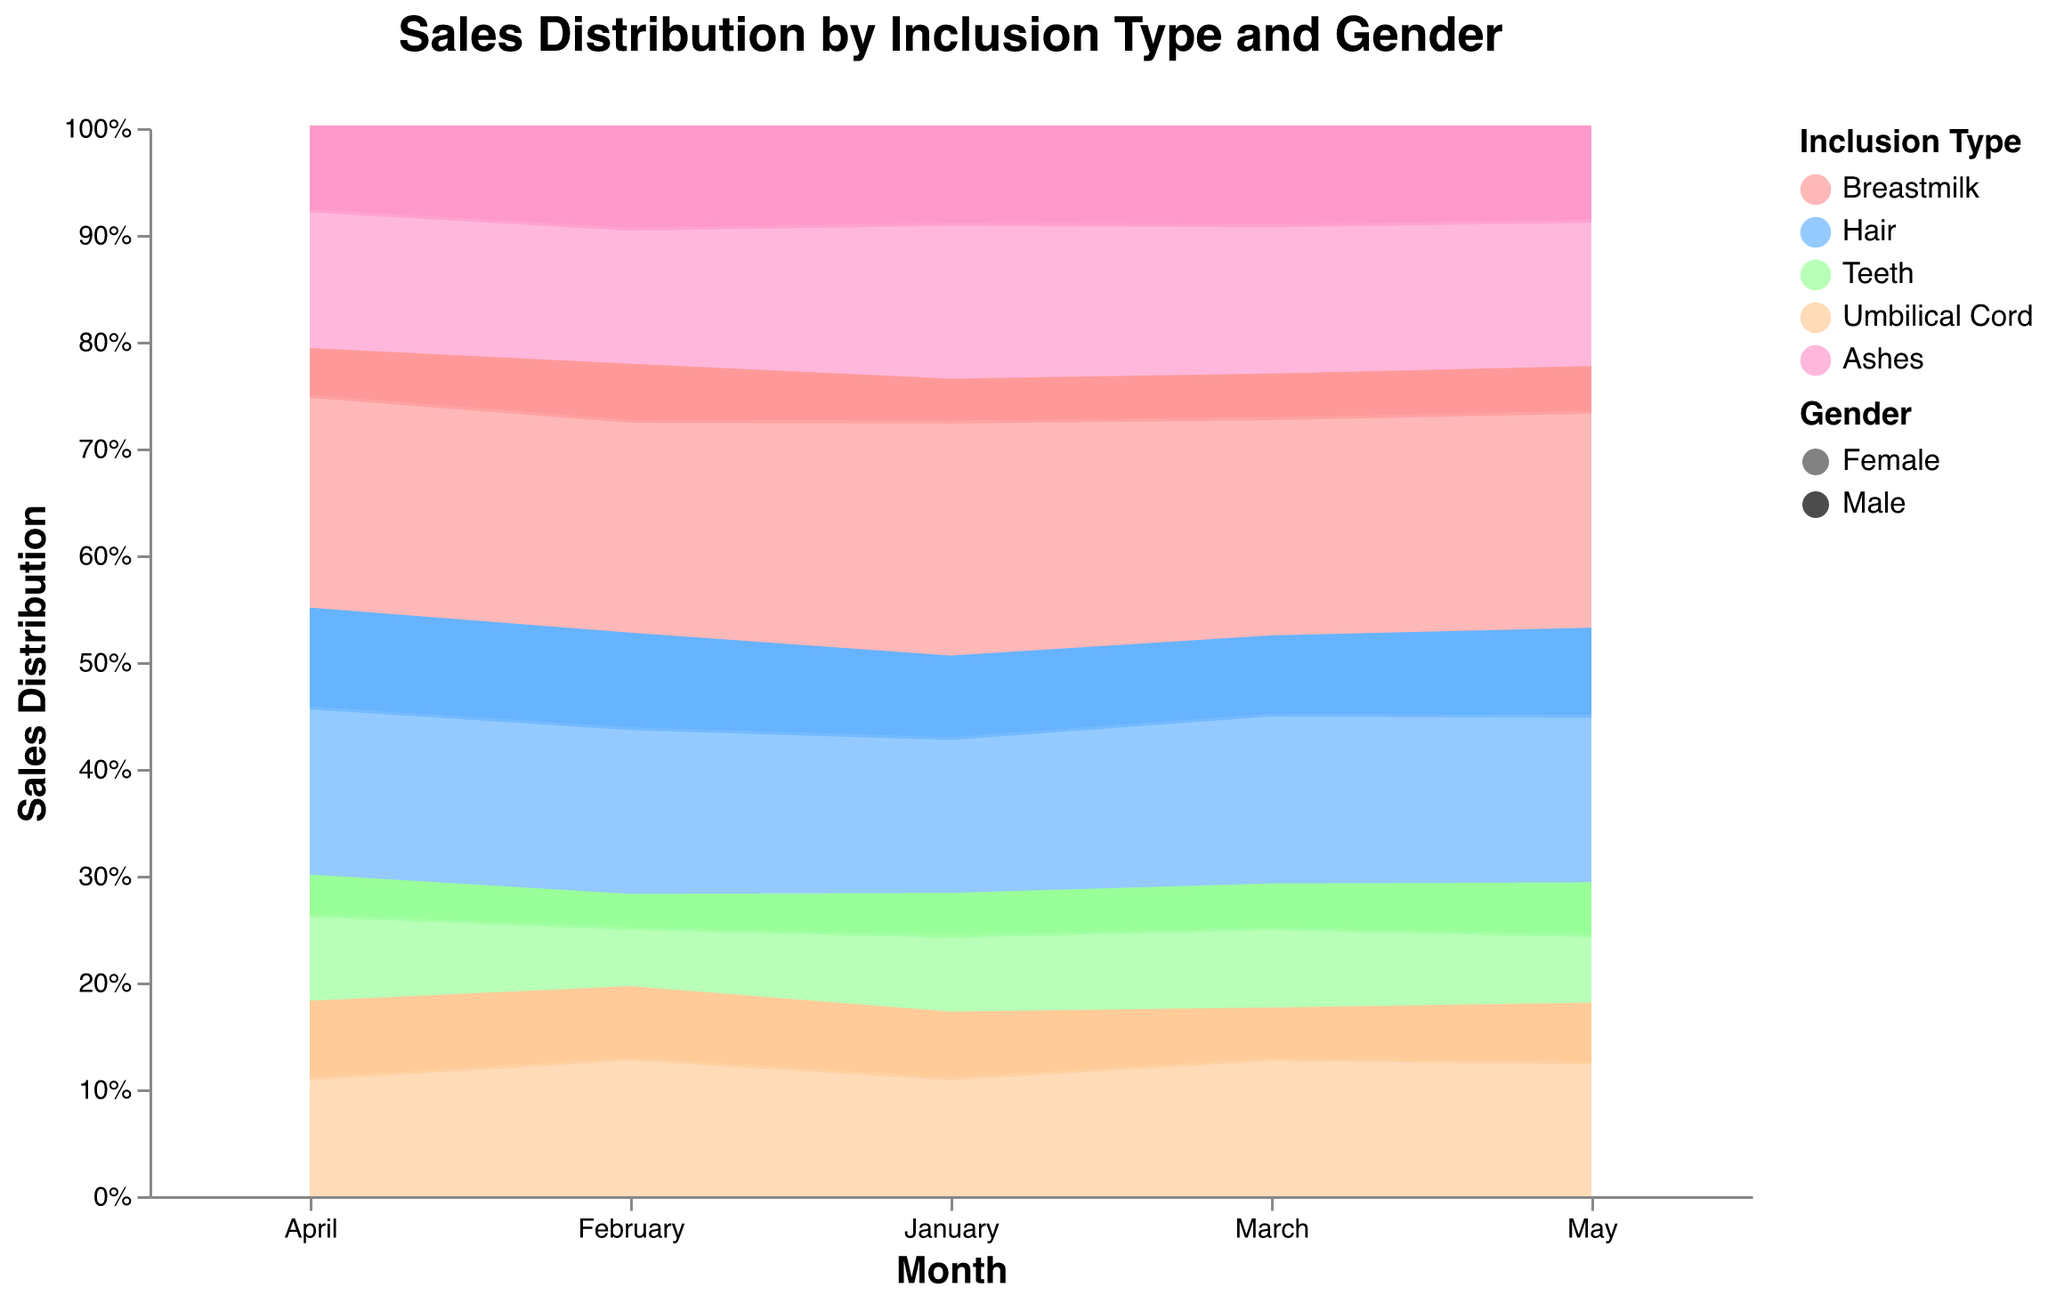What is the title of the chart? Look at the top of the chart where the title is displayed in a larger font.
Answer: Sales Distribution by Inclusion Type and Gender Which inclusion type had the highest sales in March? Observe the areas stacked in March. The largest area indicates the inclusion type with the highest sales.
Answer: Breastmilk What is the color used for the 'Hair' inclusion type? Refer to the legend on the right side of the chart. Identify the color associated with 'Hair'.
Answer: Blue Compare the sales of 'Ashes' between January and March. Which month had higher sales? Examine the areas for 'Ashes' in January and March. Compare their sizes.
Answer: March Which month had the highest proportion of sales for 'Teeth' inclusion type? Look at the proportions of 'Teeth' across all months. Identify the largest segment.
Answer: March Which gender contributed more to sales of 'Umbilical Cord' in April? Note the opacity differences within the 'Umbilical Cord' area in April. The darker area represents the dominant gender.
Answer: Male How did the sales distribution for 'Breastmilk' change from January to May? Observe the change in the size of the 'Breastmilk' area from January to May. Note the trend.
Answer: Increased If you sum up the female sales for 'Hair' for all months, what is the total? Sum the 'Hair' sales values for females from January to May (20, 22, 25, 23, 24).
Answer: 114 Which inclusion type had the most similar sales distribution for males and females during the observed months? Compare the areas for different inclusion types to find the one with similar opacity levels for both genders across months.
Answer: Teeth In May, which inclusion type had the least sales, and what is it approximately? Look at May and identify the smallest area for an inclusion type. Quantify its approximate share.
Answer: Teeth, around 6% 